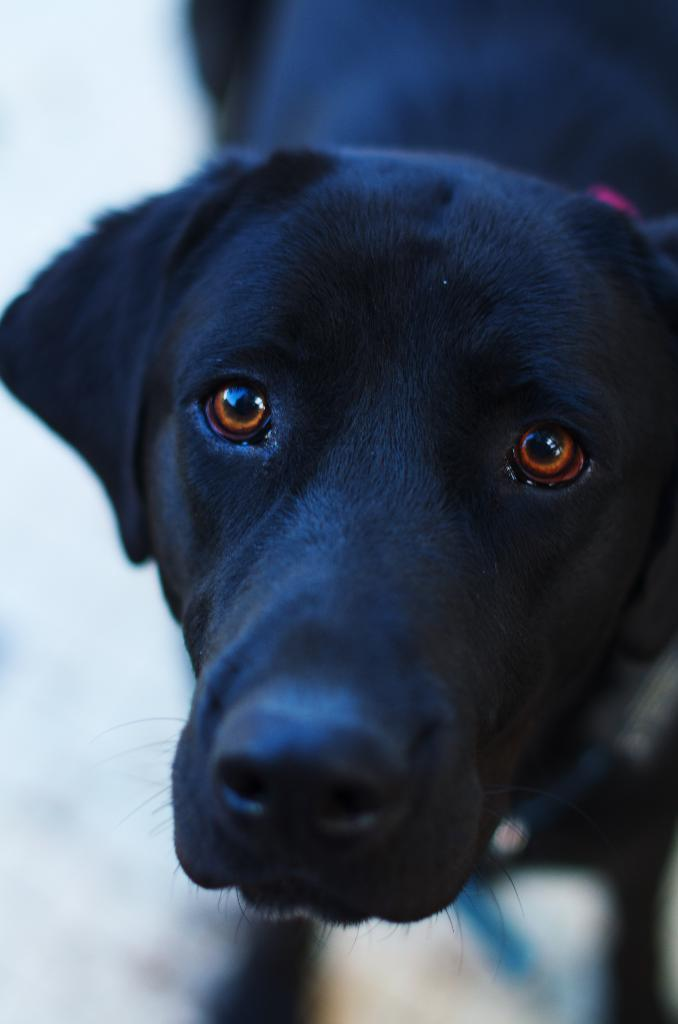What type of animal is in the picture? There is a dog in the picture. What color is the dog? The dog is black in color. Can you describe the dog's position or appearance in the image? The dog is blurred in the background. What type of waste is visible in the image? There is no waste visible in the image; it features a black dog that is blurred in the background. 